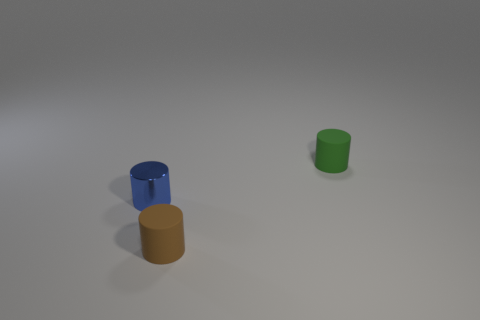There is a blue object that is the same shape as the small green rubber object; what is its material? The blue object appears to have a smooth and somewhat reflective surface, suggesting that it could be made of ceramic or plastic. Without additional context or sensory information it's challenging to determine the exact material, but its characteristics are consistent with non-metal manufactured objects, moderately reflective of light, which metal typically would be more reflective. 